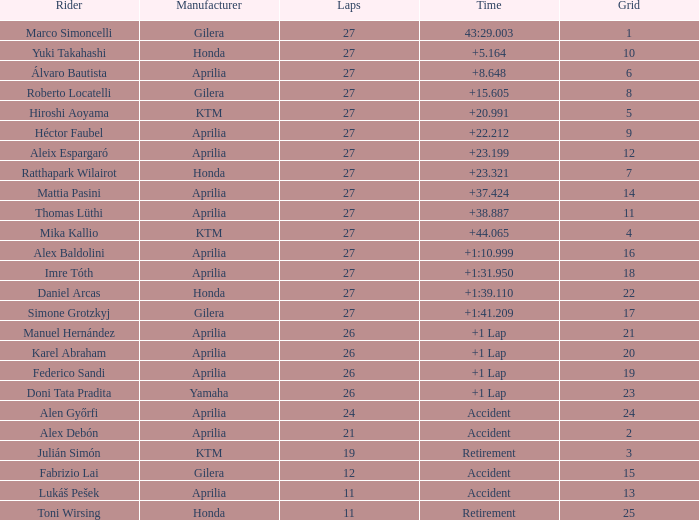Which producer has an accident time and a grid exceeding 15? Aprilia. 